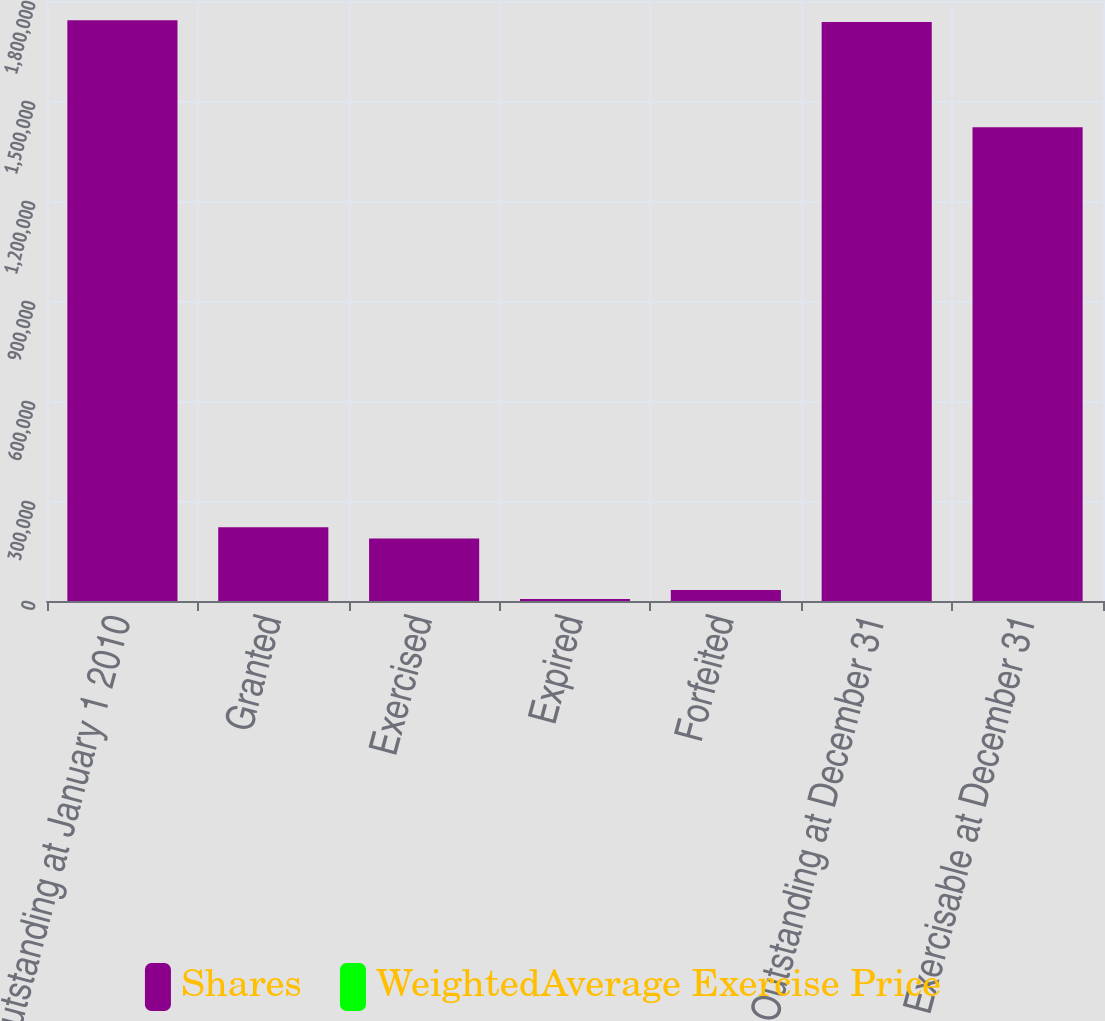Convert chart to OTSL. <chart><loc_0><loc_0><loc_500><loc_500><stacked_bar_chart><ecel><fcel>Outstanding at January 1 2010<fcel>Granted<fcel>Exercised<fcel>Expired<fcel>Forfeited<fcel>Outstanding at December 31<fcel>Exercisable at December 31<nl><fcel>Shares<fcel>1.74228e+06<fcel>221400<fcel>187599<fcel>6053<fcel>32964<fcel>1.73706e+06<fcel>1.42147e+06<nl><fcel>WeightedAverage Exercise Price<fcel>30.88<fcel>79.1<fcel>26.44<fcel>125.33<fcel>85.47<fcel>36.14<fcel>25.57<nl></chart> 